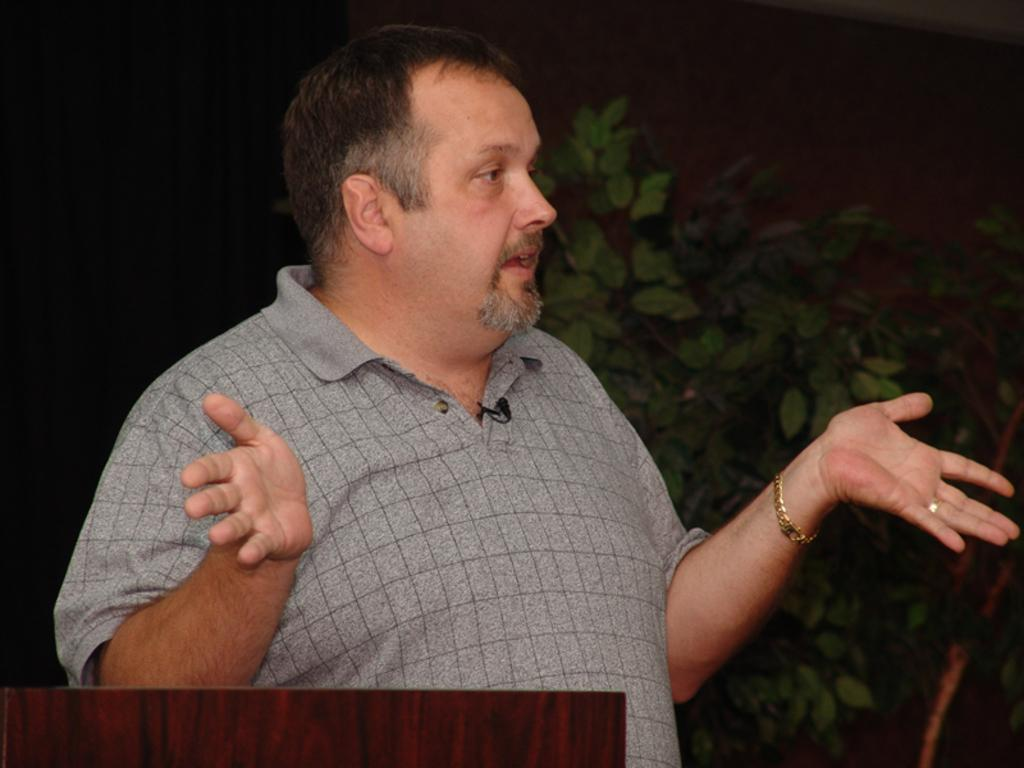Who is the main subject in the image? There is a man in the image. What is the man doing in the image? The man is showing his hands. What is the man wearing in the image? The man is wearing a t-shirt. What can be seen on the right side of the image? There are plants on the right side of the image. What type of pipe is the man holding in the image? There is no pipe present in the image; the man is showing his hands. What can be seen on the man's back in the image? The man's back is not visible in the image, as he is facing forward. 